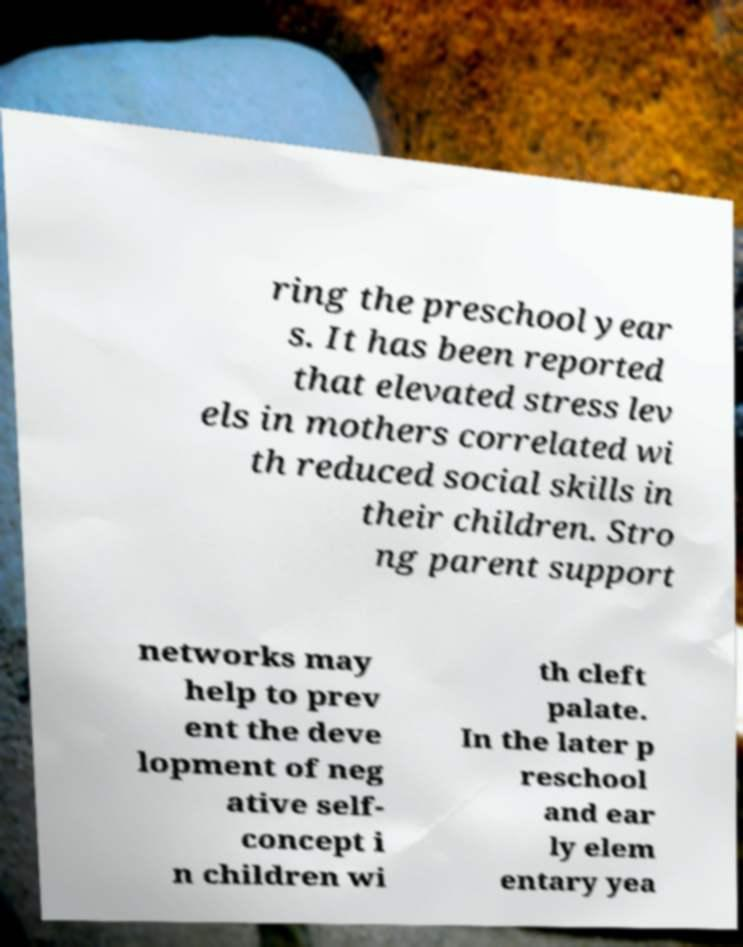Can you read and provide the text displayed in the image?This photo seems to have some interesting text. Can you extract and type it out for me? ring the preschool year s. It has been reported that elevated stress lev els in mothers correlated wi th reduced social skills in their children. Stro ng parent support networks may help to prev ent the deve lopment of neg ative self- concept i n children wi th cleft palate. In the later p reschool and ear ly elem entary yea 